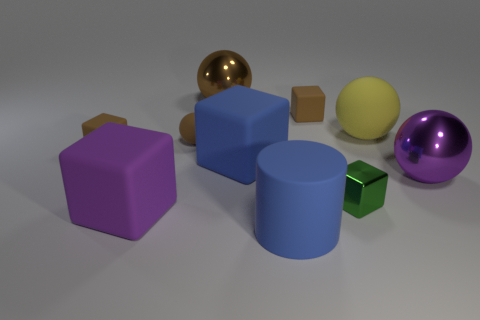There is a large yellow matte sphere behind the metallic cube; what number of tiny brown blocks are in front of it?
Provide a short and direct response. 1. There is a rubber block that is left of the small brown matte sphere and behind the purple matte object; what size is it?
Offer a very short reply. Small. Are there any other yellow rubber objects that have the same size as the yellow thing?
Ensure brevity in your answer.  No. Is the number of large blocks that are in front of the purple metal sphere greater than the number of big purple rubber things that are in front of the cylinder?
Give a very brief answer. Yes. Do the yellow object and the tiny block left of the tiny ball have the same material?
Keep it short and to the point. Yes. There is a large block that is in front of the metallic ball that is in front of the tiny rubber ball; what number of large blue objects are behind it?
Keep it short and to the point. 1. Does the yellow matte object have the same shape as the large rubber thing that is left of the tiny brown rubber sphere?
Ensure brevity in your answer.  No. There is a object that is both in front of the purple shiny ball and behind the big purple matte block; what is its color?
Keep it short and to the point. Green. There is a tiny object in front of the metallic ball to the right of the blue object in front of the big purple shiny sphere; what is its material?
Your answer should be very brief. Metal. What material is the blue cylinder?
Offer a very short reply. Rubber. 